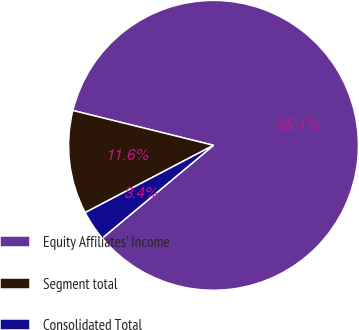<chart> <loc_0><loc_0><loc_500><loc_500><pie_chart><fcel>Equity Affiliates' Income<fcel>Segment total<fcel>Consolidated Total<nl><fcel>85.07%<fcel>11.55%<fcel>3.38%<nl></chart> 